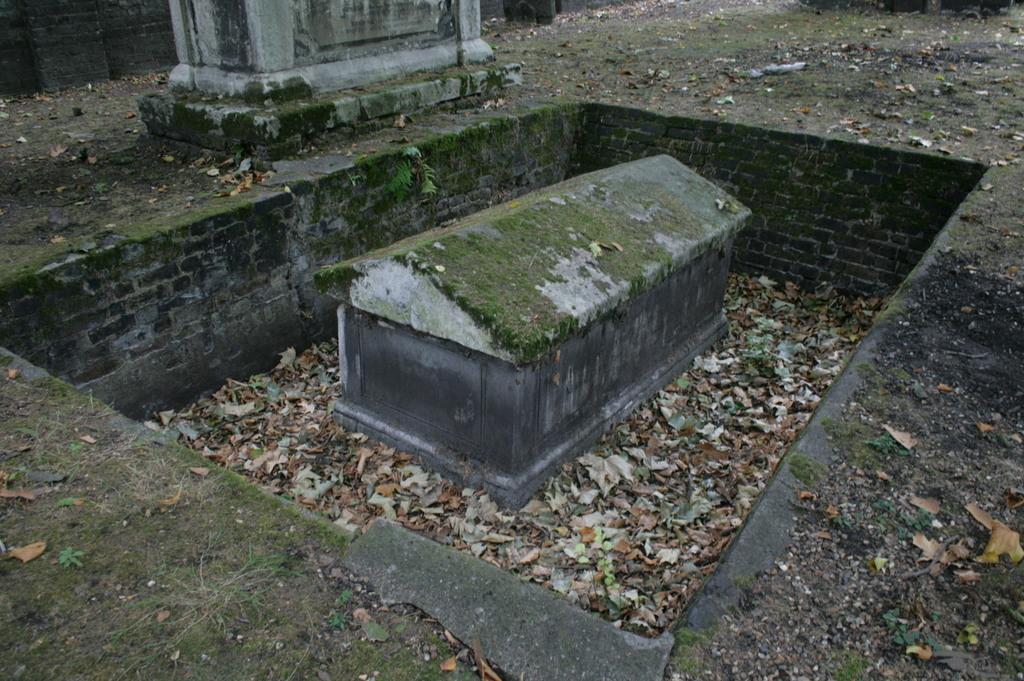Please provide a concise description of this image. In the center of the image there is a gravestone. There are dried leaves. At the bottom of the image there is grass. 